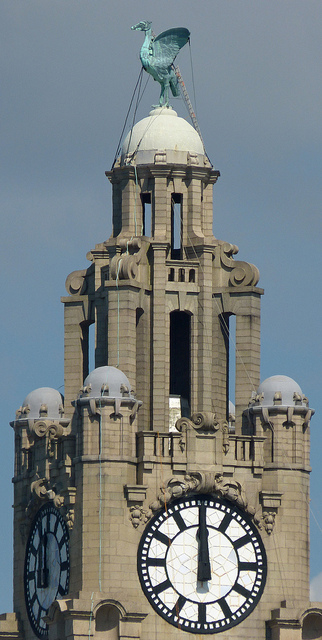<image>Which house appears to have a window box? I don't know which house appears to have a window box. Is the clock showing the right time? It's unclear if the clock is showing the right time. What bird is represented on the building? I can't determine what bird is represented on the building. It could be a peacock, stork, eagle, swan, goose, or even a dragon. Which house appears to have a window box? I don't know which house appears to have a window box. None of the options seem to indicate a window box. Is the clock showing the right time? I don't know if the clock is showing the right time. It can be both right or wrong. What bird is represented on the building? I don't know what bird is represented on the building. It can be seen 'peacock', 'stork', 'eagle', 'swan', 'goose', or 'dragon'. 